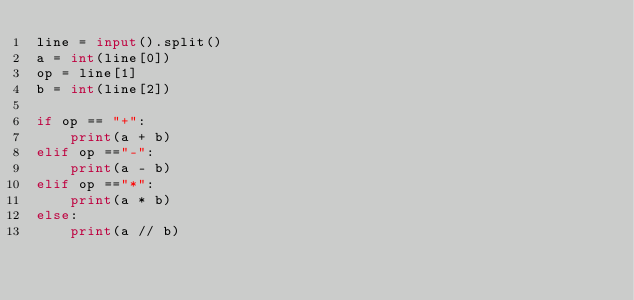Convert code to text. <code><loc_0><loc_0><loc_500><loc_500><_Python_>line = input().split()
a = int(line[0])
op = line[1]
b = int(line[2])

if op == "+":
    print(a + b)
elif op =="-":
    print(a - b)
elif op =="*":
    print(a * b)
else:
    print(a // b)


</code> 